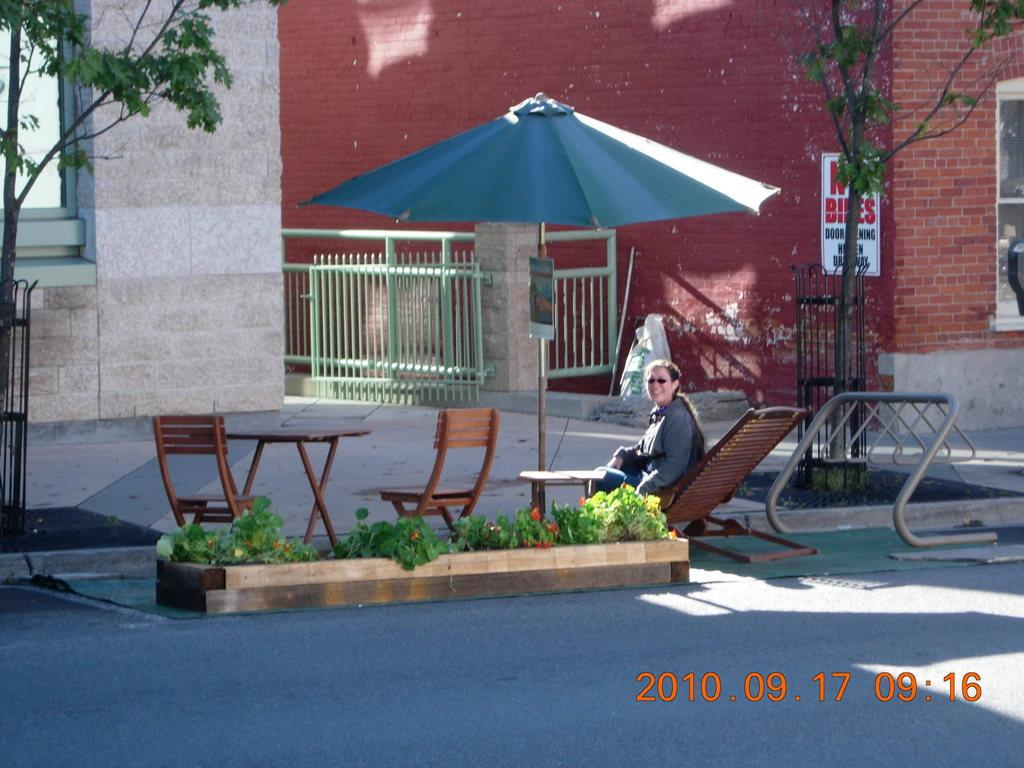Who is present in the image? There is a woman in the image. What is the woman doing in the image? The woman is sitting on a chair. What is the woman's facial expression in the image? The woman is smiling. What is providing shade for the woman in the image? The woman is under an umbrella. How many snakes are wrapped around the woman's chair in the image? There are no snakes present in the image. What type of rock is the woman sitting on in the image? The woman is sitting on a chair, not a rock. 